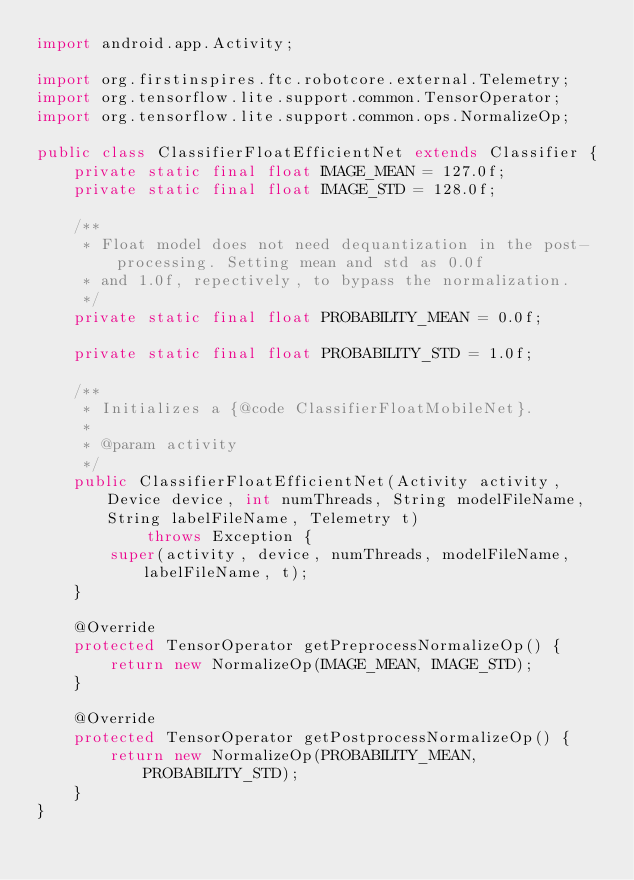Convert code to text. <code><loc_0><loc_0><loc_500><loc_500><_Java_>import android.app.Activity;

import org.firstinspires.ftc.robotcore.external.Telemetry;
import org.tensorflow.lite.support.common.TensorOperator;
import org.tensorflow.lite.support.common.ops.NormalizeOp;

public class ClassifierFloatEfficientNet extends Classifier {
    private static final float IMAGE_MEAN = 127.0f;
    private static final float IMAGE_STD = 128.0f;

    /**
     * Float model does not need dequantization in the post-processing. Setting mean and std as 0.0f
     * and 1.0f, repectively, to bypass the normalization.
     */
    private static final float PROBABILITY_MEAN = 0.0f;

    private static final float PROBABILITY_STD = 1.0f;

    /**
     * Initializes a {@code ClassifierFloatMobileNet}.
     *
     * @param activity
     */
    public ClassifierFloatEfficientNet(Activity activity, Device device, int numThreads, String modelFileName, String labelFileName, Telemetry t)
            throws Exception {
        super(activity, device, numThreads, modelFileName, labelFileName, t);
    }

    @Override
    protected TensorOperator getPreprocessNormalizeOp() {
        return new NormalizeOp(IMAGE_MEAN, IMAGE_STD);
    }

    @Override
    protected TensorOperator getPostprocessNormalizeOp() {
        return new NormalizeOp(PROBABILITY_MEAN, PROBABILITY_STD);
    }
}
</code> 